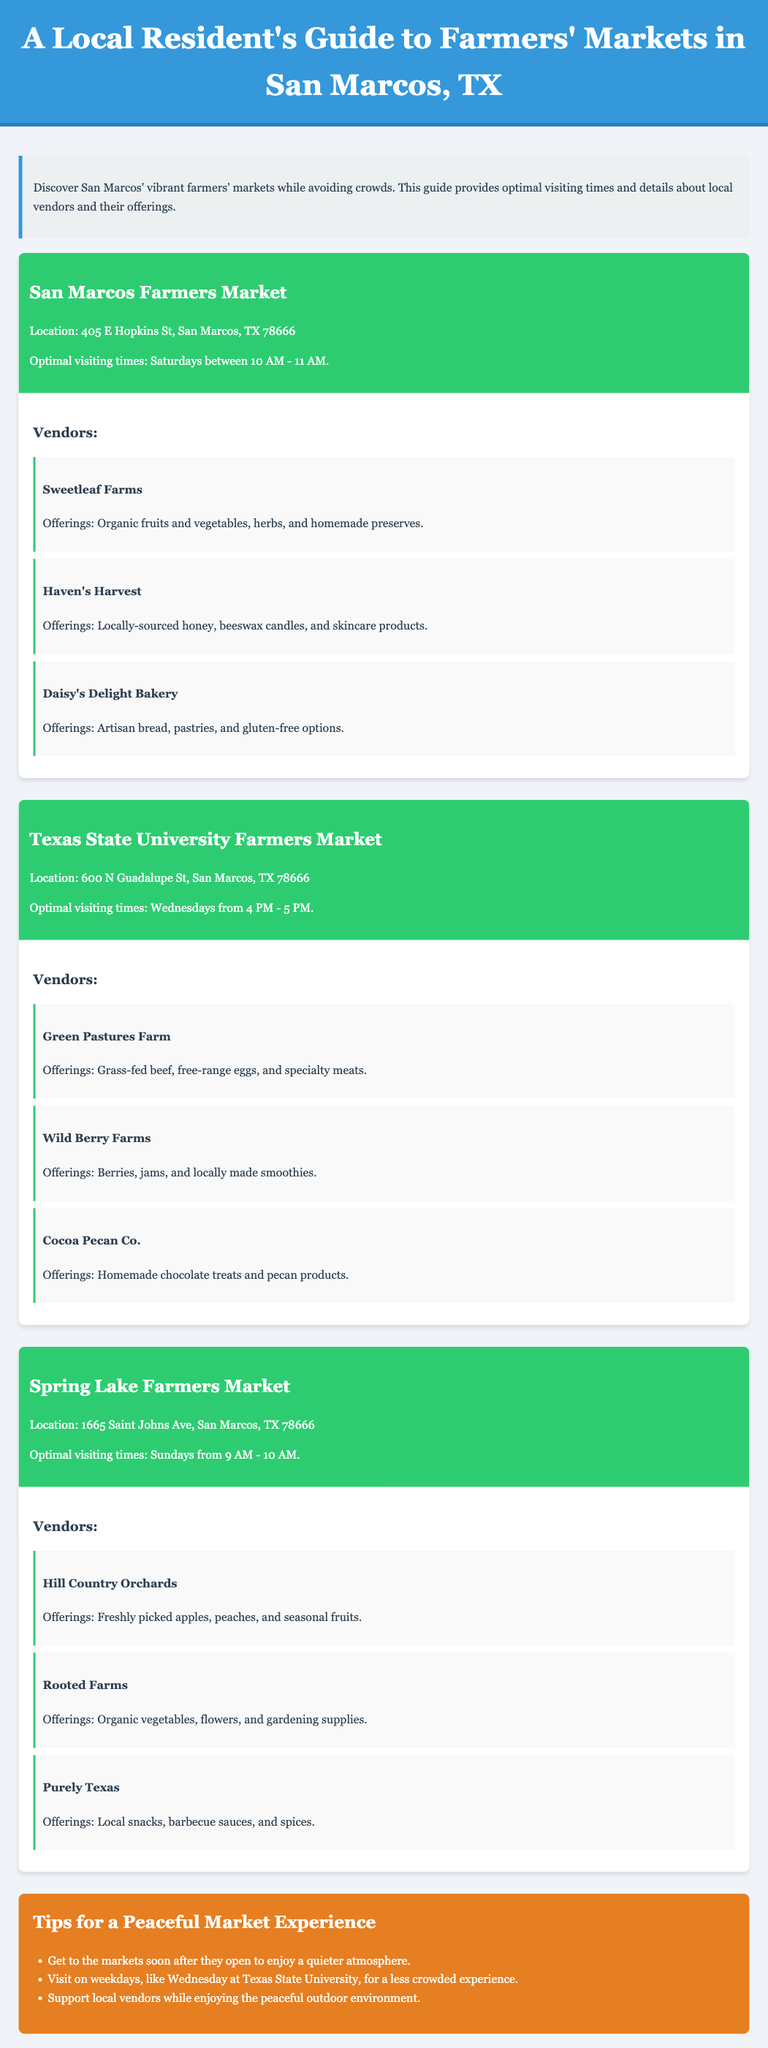What is the location of the San Marcos Farmers Market? The location of the San Marcos Farmers Market is listed in the document as 405 E Hopkins St, San Marcos, TX 78666.
Answer: 405 E Hopkins St, San Marcos, TX 78666 What is the optimal visiting time for the Texas State University Farmers Market? The document specifies the optimal visiting time for the Texas State University Farmers Market as Wednesdays from 4 PM - 5 PM.
Answer: Wednesdays from 4 PM - 5 PM Which vendor offers organic vegetables, flowers, and gardening supplies? According to the vendor listings, Rooted Farms offers organic vegetables, flowers, and gardening supplies.
Answer: Rooted Farms What is the recommended visiting time to avoid crowds at the San Marcos Farmers Market? The document recommends visiting the San Marcos Farmers Market on Saturdays between 10 AM - 11 AM to avoid crowds.
Answer: Saturdays between 10 AM - 11 AM How many vendors are listed for the Spring Lake Farmers Market? The document states that there are three vendors listed for the Spring Lake Farmers Market.
Answer: Three vendors What type of products does Haven's Harvest sell? The products offered by Haven's Harvest, as mentioned in the document, include locally-sourced honey, beeswax candles, and skincare products.
Answer: Locally-sourced honey, beeswax candles, and skincare products What day is optimal for a less crowded market experience at Texas State University? The document specifies Wednesday as the optimal day for a less crowded experience at Texas State University Farmers Market.
Answer: Wednesday What is the primary focus of the tips section in the document? The tips section aims to provide guidance on how to have a peaceful market experience while visiting.
Answer: Peaceful market experience 